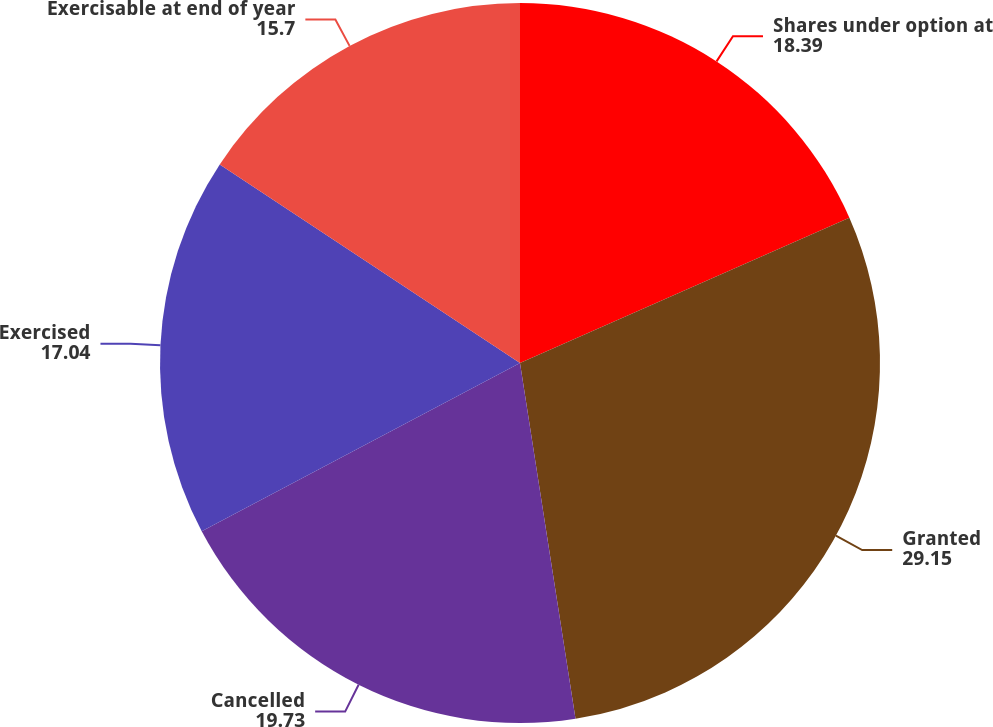<chart> <loc_0><loc_0><loc_500><loc_500><pie_chart><fcel>Shares under option at<fcel>Granted<fcel>Cancelled<fcel>Exercised<fcel>Exercisable at end of year<nl><fcel>18.39%<fcel>29.15%<fcel>19.73%<fcel>17.04%<fcel>15.7%<nl></chart> 